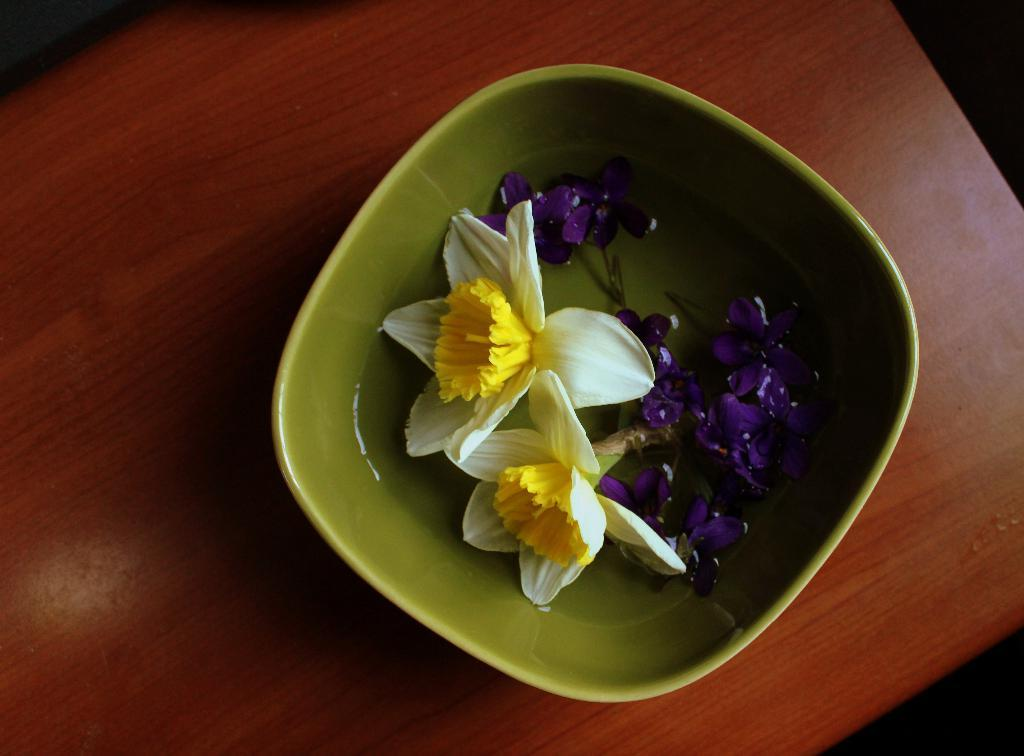What color is the bowl in the image? The bowl in the image is green. What is inside the bowl? The bowl contains flowers and water. On what surface is the bowl placed? The bowl is placed on a wooden table. What type of brass instrument can be seen in the image? There is no brass instrument present in the image; it features a green bowl with flowers and water on a wooden table. 